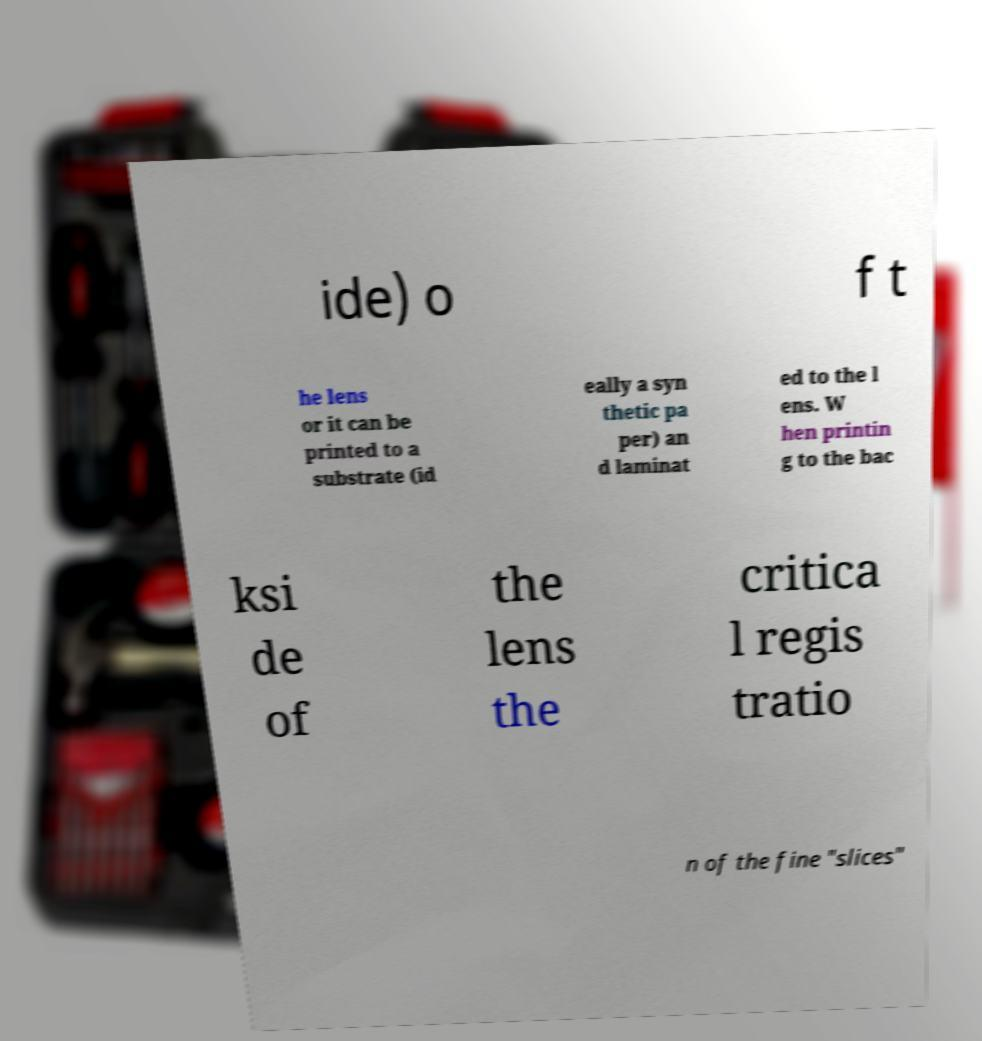Could you extract and type out the text from this image? ide) o f t he lens or it can be printed to a substrate (id eally a syn thetic pa per) an d laminat ed to the l ens. W hen printin g to the bac ksi de of the lens the critica l regis tratio n of the fine "slices" 